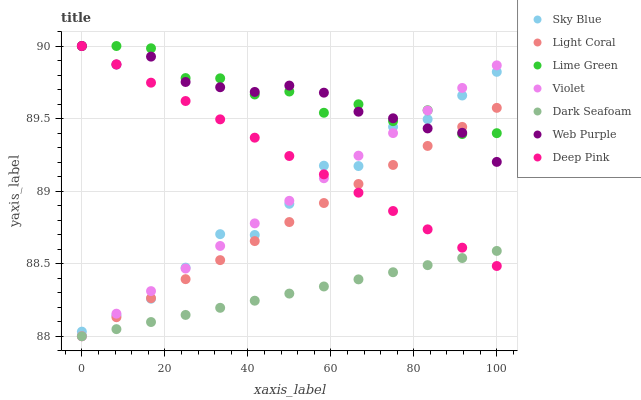Does Dark Seafoam have the minimum area under the curve?
Answer yes or no. Yes. Does Lime Green have the maximum area under the curve?
Answer yes or no. Yes. Does Web Purple have the minimum area under the curve?
Answer yes or no. No. Does Web Purple have the maximum area under the curve?
Answer yes or no. No. Is Dark Seafoam the smoothest?
Answer yes or no. Yes. Is Lime Green the roughest?
Answer yes or no. Yes. Is Web Purple the smoothest?
Answer yes or no. No. Is Web Purple the roughest?
Answer yes or no. No. Does Light Coral have the lowest value?
Answer yes or no. Yes. Does Web Purple have the lowest value?
Answer yes or no. No. Does Lime Green have the highest value?
Answer yes or no. Yes. Does Light Coral have the highest value?
Answer yes or no. No. Is Dark Seafoam less than Sky Blue?
Answer yes or no. Yes. Is Sky Blue greater than Dark Seafoam?
Answer yes or no. Yes. Does Dark Seafoam intersect Light Coral?
Answer yes or no. Yes. Is Dark Seafoam less than Light Coral?
Answer yes or no. No. Is Dark Seafoam greater than Light Coral?
Answer yes or no. No. Does Dark Seafoam intersect Sky Blue?
Answer yes or no. No. 